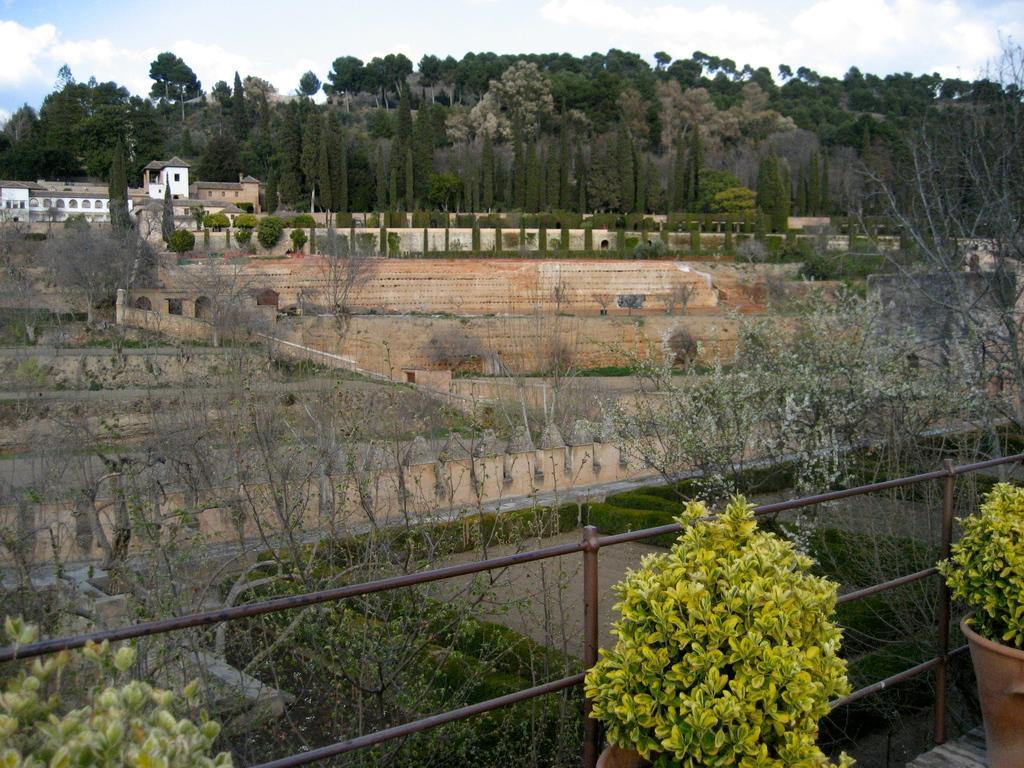Please provide a concise description of this image. In the image there are plants, dry trees and behind the dry trees there are walls and in the background there is a building on the left side, behind the building there are plenty of trees. 